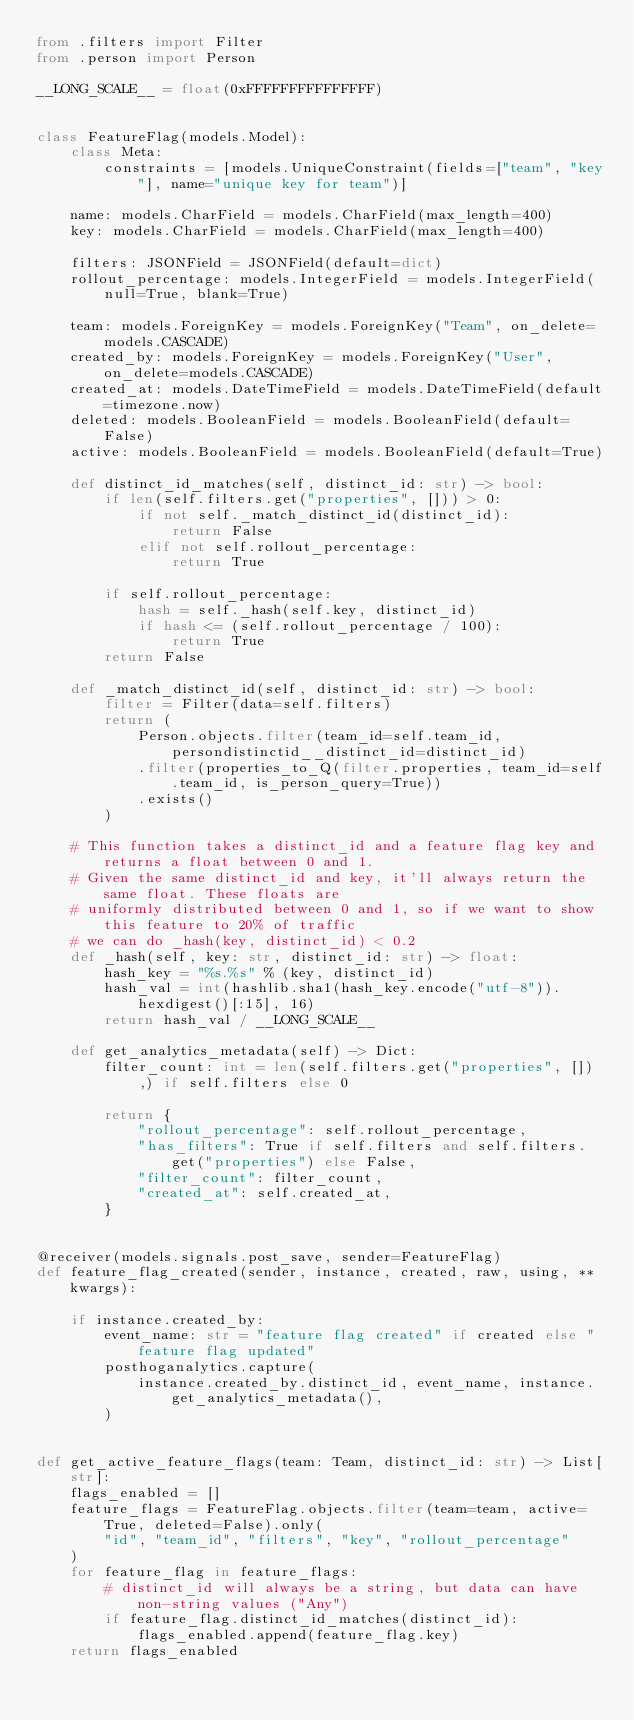<code> <loc_0><loc_0><loc_500><loc_500><_Python_>from .filters import Filter
from .person import Person

__LONG_SCALE__ = float(0xFFFFFFFFFFFFFFF)


class FeatureFlag(models.Model):
    class Meta:
        constraints = [models.UniqueConstraint(fields=["team", "key"], name="unique key for team")]

    name: models.CharField = models.CharField(max_length=400)
    key: models.CharField = models.CharField(max_length=400)

    filters: JSONField = JSONField(default=dict)
    rollout_percentage: models.IntegerField = models.IntegerField(null=True, blank=True)

    team: models.ForeignKey = models.ForeignKey("Team", on_delete=models.CASCADE)
    created_by: models.ForeignKey = models.ForeignKey("User", on_delete=models.CASCADE)
    created_at: models.DateTimeField = models.DateTimeField(default=timezone.now)
    deleted: models.BooleanField = models.BooleanField(default=False)
    active: models.BooleanField = models.BooleanField(default=True)

    def distinct_id_matches(self, distinct_id: str) -> bool:
        if len(self.filters.get("properties", [])) > 0:
            if not self._match_distinct_id(distinct_id):
                return False
            elif not self.rollout_percentage:
                return True

        if self.rollout_percentage:
            hash = self._hash(self.key, distinct_id)
            if hash <= (self.rollout_percentage / 100):
                return True
        return False

    def _match_distinct_id(self, distinct_id: str) -> bool:
        filter = Filter(data=self.filters)
        return (
            Person.objects.filter(team_id=self.team_id, persondistinctid__distinct_id=distinct_id)
            .filter(properties_to_Q(filter.properties, team_id=self.team_id, is_person_query=True))
            .exists()
        )

    # This function takes a distinct_id and a feature flag key and returns a float between 0 and 1.
    # Given the same distinct_id and key, it'll always return the same float. These floats are
    # uniformly distributed between 0 and 1, so if we want to show this feature to 20% of traffic
    # we can do _hash(key, distinct_id) < 0.2
    def _hash(self, key: str, distinct_id: str) -> float:
        hash_key = "%s.%s" % (key, distinct_id)
        hash_val = int(hashlib.sha1(hash_key.encode("utf-8")).hexdigest()[:15], 16)
        return hash_val / __LONG_SCALE__

    def get_analytics_metadata(self) -> Dict:
        filter_count: int = len(self.filters.get("properties", []),) if self.filters else 0

        return {
            "rollout_percentage": self.rollout_percentage,
            "has_filters": True if self.filters and self.filters.get("properties") else False,
            "filter_count": filter_count,
            "created_at": self.created_at,
        }


@receiver(models.signals.post_save, sender=FeatureFlag)
def feature_flag_created(sender, instance, created, raw, using, **kwargs):

    if instance.created_by:
        event_name: str = "feature flag created" if created else "feature flag updated"
        posthoganalytics.capture(
            instance.created_by.distinct_id, event_name, instance.get_analytics_metadata(),
        )


def get_active_feature_flags(team: Team, distinct_id: str) -> List[str]:
    flags_enabled = []
    feature_flags = FeatureFlag.objects.filter(team=team, active=True, deleted=False).only(
        "id", "team_id", "filters", "key", "rollout_percentage"
    )
    for feature_flag in feature_flags:
        # distinct_id will always be a string, but data can have non-string values ("Any")
        if feature_flag.distinct_id_matches(distinct_id):
            flags_enabled.append(feature_flag.key)
    return flags_enabled
</code> 